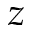Convert formula to latex. <formula><loc_0><loc_0><loc_500><loc_500>z</formula> 